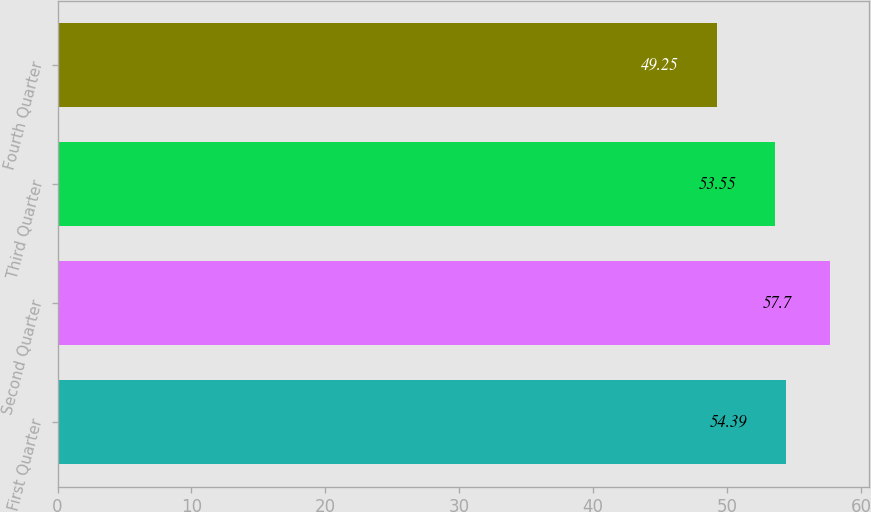Convert chart to OTSL. <chart><loc_0><loc_0><loc_500><loc_500><bar_chart><fcel>First Quarter<fcel>Second Quarter<fcel>Third Quarter<fcel>Fourth Quarter<nl><fcel>54.39<fcel>57.7<fcel>53.55<fcel>49.25<nl></chart> 